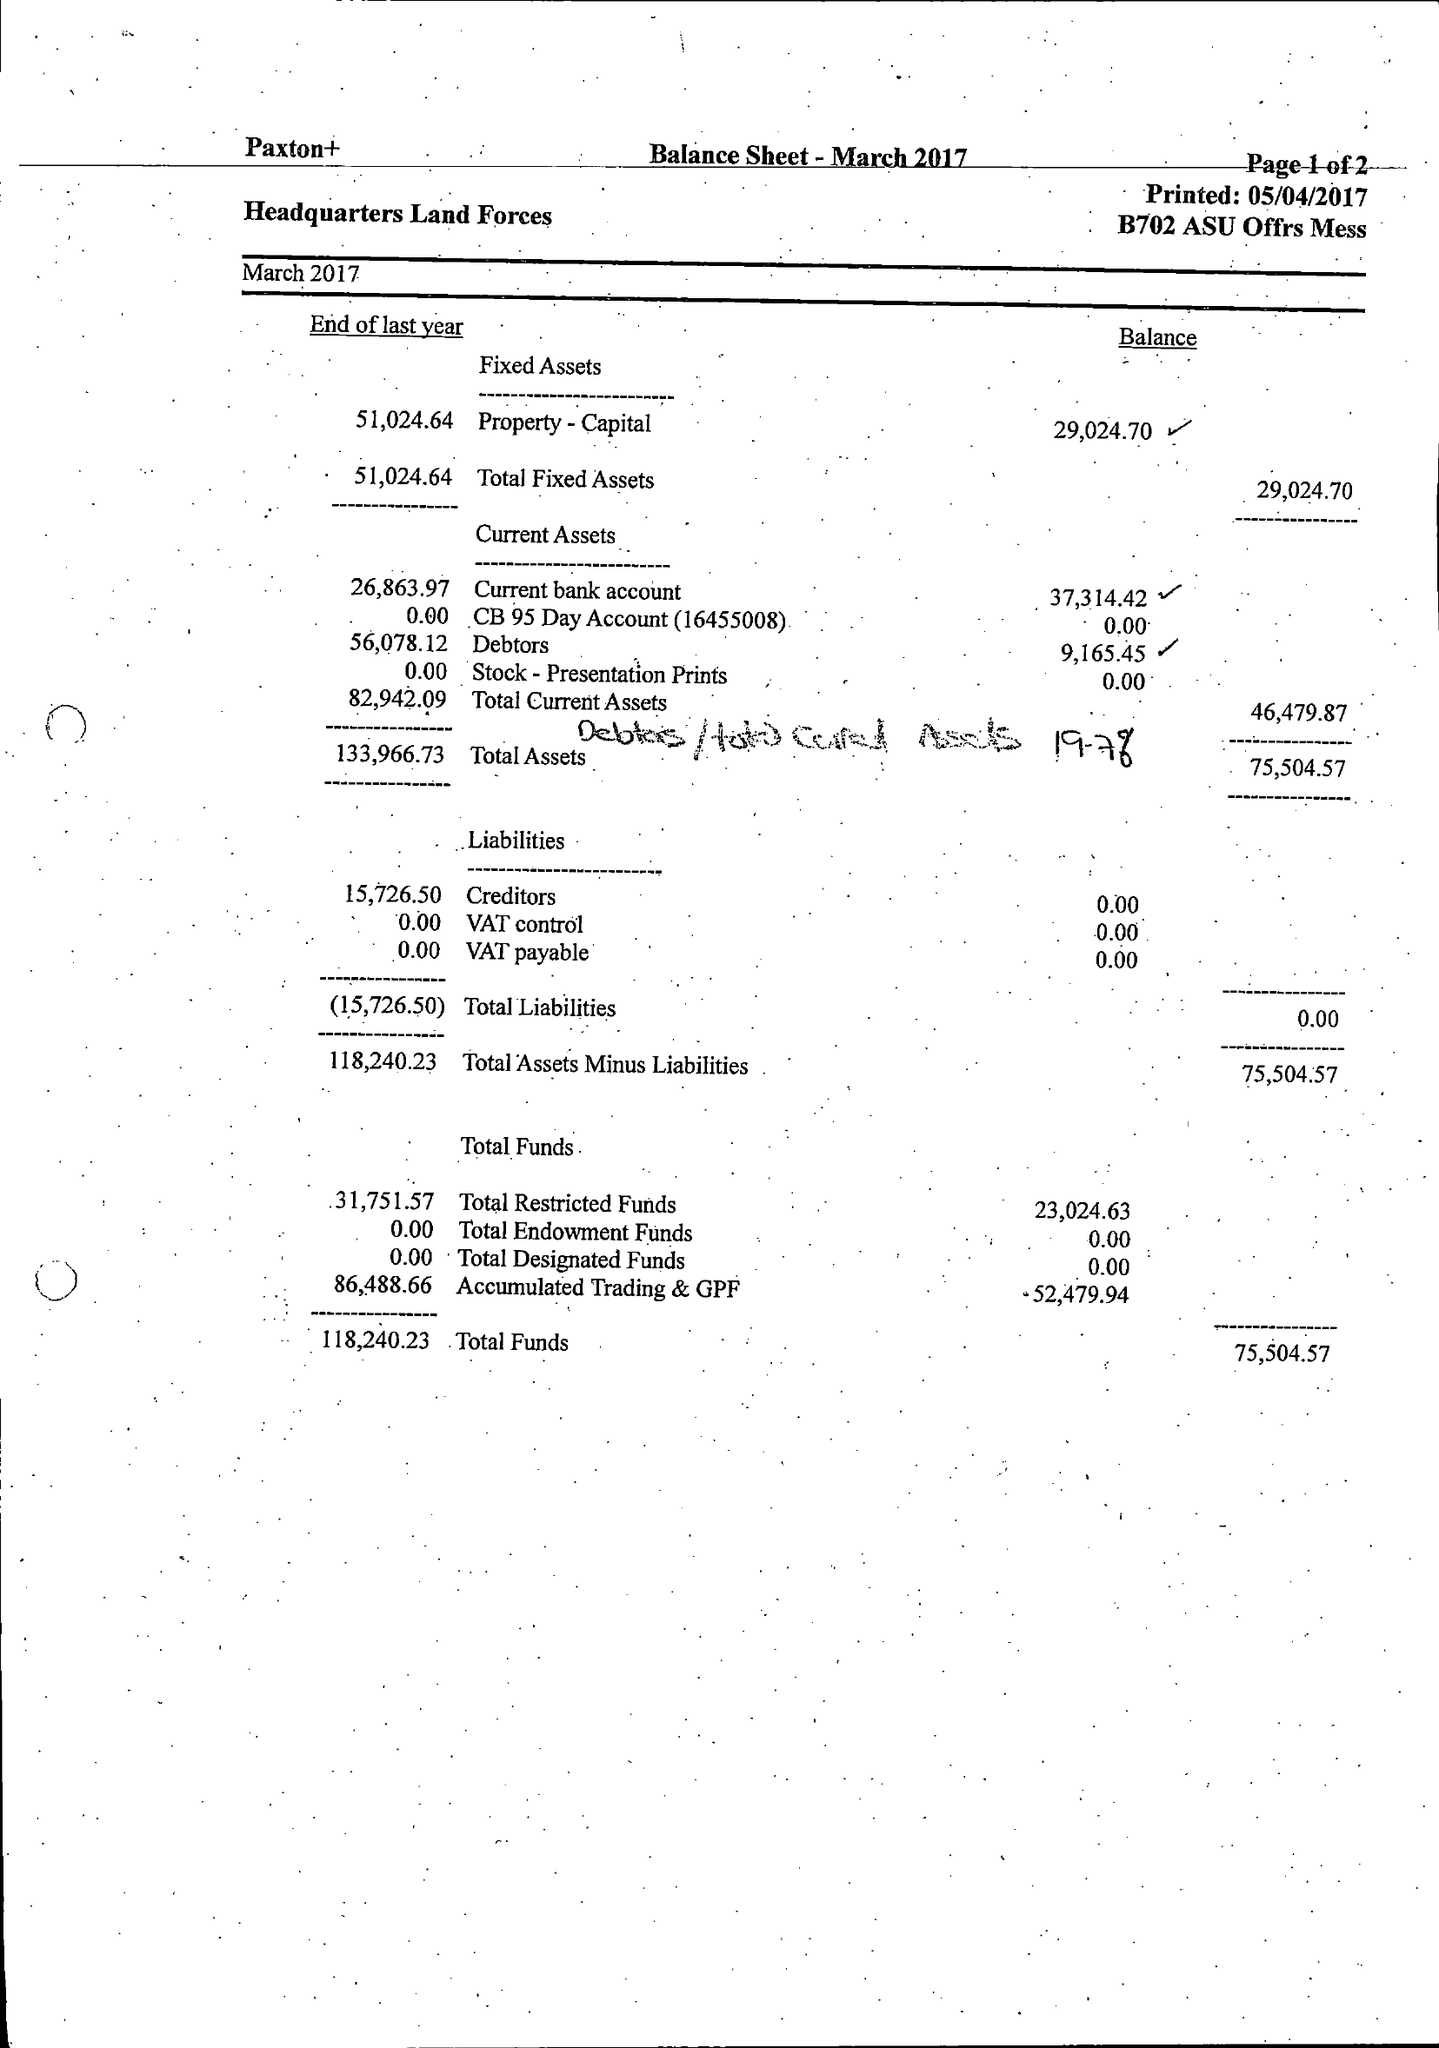What is the value for the income_annually_in_british_pounds?
Answer the question using a single word or phrase. 115205.00 